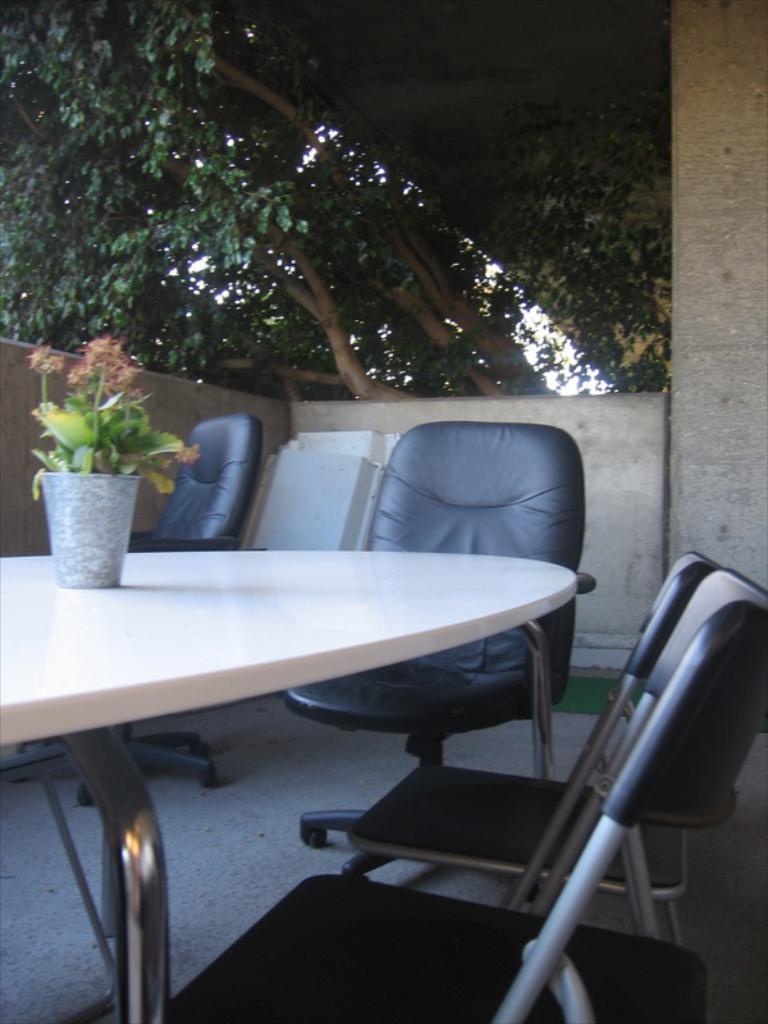In one or two sentences, can you explain what this image depicts? this is a balcony there are many chairs and table on the table there is a house plant near to the balcony there are trees 